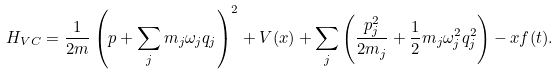Convert formula to latex. <formula><loc_0><loc_0><loc_500><loc_500>H _ { V C } = \frac { 1 } { 2 m } \left ( p + \sum _ { j } m _ { j } \omega _ { j } q _ { j } \right ) ^ { 2 } + V ( x ) + \sum _ { j } \left ( \frac { p ^ { 2 } _ { j } } { 2 m _ { j } } + \frac { 1 } { 2 } m _ { j } \omega ^ { 2 } _ { j } q ^ { 2 } _ { j } \right ) - x f ( t ) .</formula> 